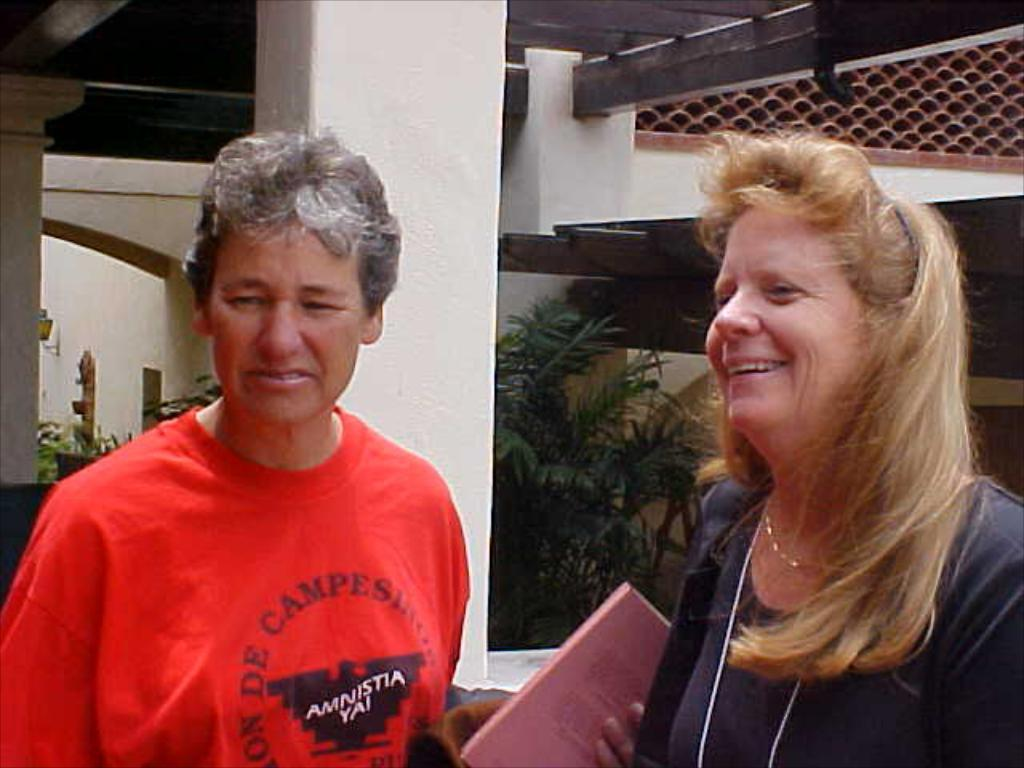How many people are in the image? There are two persons in the image. What is the person on the left side wearing? The person on the left side is wearing a red T-shirt. What is the expression of the person on the right side? The person on the right side is smiling. What can be seen in the background of the image? There are plants visible in the background of the image. What type of wall did the person on the left side lose their belief in? There is no mention of a wall or loss of belief in the image. 